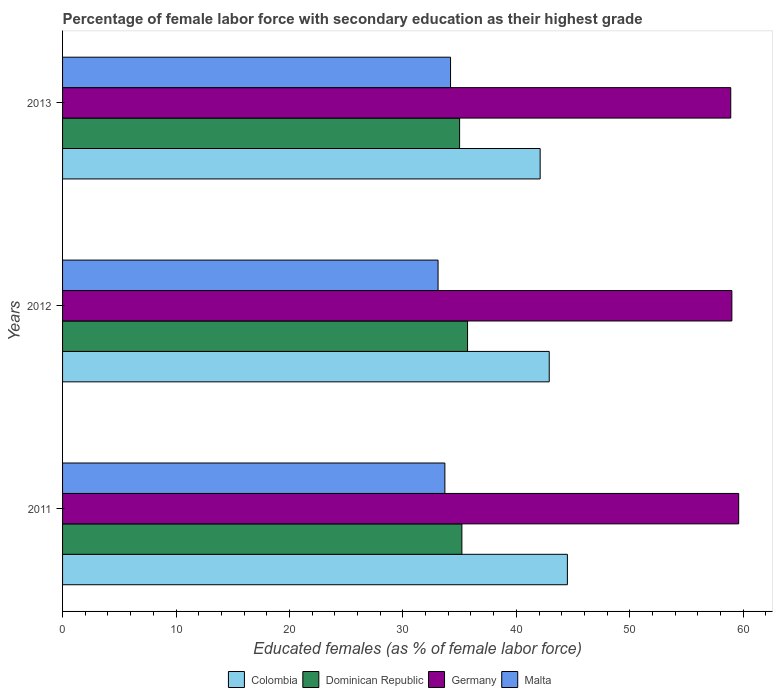Are the number of bars per tick equal to the number of legend labels?
Provide a succinct answer. Yes. How many bars are there on the 2nd tick from the top?
Provide a succinct answer. 4. How many bars are there on the 1st tick from the bottom?
Provide a succinct answer. 4. What is the label of the 2nd group of bars from the top?
Your answer should be very brief. 2012. What is the percentage of female labor force with secondary education in Malta in 2013?
Your answer should be compact. 34.2. Across all years, what is the maximum percentage of female labor force with secondary education in Colombia?
Your answer should be very brief. 44.5. Across all years, what is the minimum percentage of female labor force with secondary education in Malta?
Ensure brevity in your answer.  33.1. What is the total percentage of female labor force with secondary education in Dominican Republic in the graph?
Make the answer very short. 105.9. What is the difference between the percentage of female labor force with secondary education in Colombia in 2011 and that in 2013?
Offer a very short reply. 2.4. What is the difference between the percentage of female labor force with secondary education in Malta in 2011 and the percentage of female labor force with secondary education in Colombia in 2013?
Offer a terse response. -8.4. What is the average percentage of female labor force with secondary education in Germany per year?
Your answer should be compact. 59.17. In the year 2012, what is the difference between the percentage of female labor force with secondary education in Germany and percentage of female labor force with secondary education in Colombia?
Your response must be concise. 16.1. What is the ratio of the percentage of female labor force with secondary education in Germany in 2011 to that in 2013?
Your answer should be compact. 1.01. Is the percentage of female labor force with secondary education in Malta in 2012 less than that in 2013?
Your response must be concise. Yes. What is the difference between the highest and the lowest percentage of female labor force with secondary education in Colombia?
Make the answer very short. 2.4. In how many years, is the percentage of female labor force with secondary education in Malta greater than the average percentage of female labor force with secondary education in Malta taken over all years?
Your answer should be compact. 2. Is the sum of the percentage of female labor force with secondary education in Colombia in 2011 and 2013 greater than the maximum percentage of female labor force with secondary education in Dominican Republic across all years?
Your response must be concise. Yes. How many bars are there?
Provide a succinct answer. 12. Are all the bars in the graph horizontal?
Provide a short and direct response. Yes. Does the graph contain any zero values?
Make the answer very short. No. What is the title of the graph?
Make the answer very short. Percentage of female labor force with secondary education as their highest grade. What is the label or title of the X-axis?
Provide a succinct answer. Educated females (as % of female labor force). What is the Educated females (as % of female labor force) in Colombia in 2011?
Provide a short and direct response. 44.5. What is the Educated females (as % of female labor force) of Dominican Republic in 2011?
Give a very brief answer. 35.2. What is the Educated females (as % of female labor force) in Germany in 2011?
Provide a succinct answer. 59.6. What is the Educated females (as % of female labor force) in Malta in 2011?
Keep it short and to the point. 33.7. What is the Educated females (as % of female labor force) in Colombia in 2012?
Provide a short and direct response. 42.9. What is the Educated females (as % of female labor force) of Dominican Republic in 2012?
Ensure brevity in your answer.  35.7. What is the Educated females (as % of female labor force) in Malta in 2012?
Your answer should be very brief. 33.1. What is the Educated females (as % of female labor force) in Colombia in 2013?
Give a very brief answer. 42.1. What is the Educated females (as % of female labor force) of Dominican Republic in 2013?
Keep it short and to the point. 35. What is the Educated females (as % of female labor force) of Germany in 2013?
Give a very brief answer. 58.9. What is the Educated females (as % of female labor force) in Malta in 2013?
Make the answer very short. 34.2. Across all years, what is the maximum Educated females (as % of female labor force) in Colombia?
Your response must be concise. 44.5. Across all years, what is the maximum Educated females (as % of female labor force) of Dominican Republic?
Make the answer very short. 35.7. Across all years, what is the maximum Educated females (as % of female labor force) of Germany?
Your answer should be very brief. 59.6. Across all years, what is the maximum Educated females (as % of female labor force) of Malta?
Your response must be concise. 34.2. Across all years, what is the minimum Educated females (as % of female labor force) in Colombia?
Offer a very short reply. 42.1. Across all years, what is the minimum Educated females (as % of female labor force) in Dominican Republic?
Your answer should be compact. 35. Across all years, what is the minimum Educated females (as % of female labor force) in Germany?
Your answer should be very brief. 58.9. Across all years, what is the minimum Educated females (as % of female labor force) in Malta?
Provide a succinct answer. 33.1. What is the total Educated females (as % of female labor force) of Colombia in the graph?
Give a very brief answer. 129.5. What is the total Educated females (as % of female labor force) of Dominican Republic in the graph?
Your answer should be very brief. 105.9. What is the total Educated females (as % of female labor force) of Germany in the graph?
Your answer should be very brief. 177.5. What is the total Educated females (as % of female labor force) in Malta in the graph?
Provide a succinct answer. 101. What is the difference between the Educated females (as % of female labor force) of Germany in 2011 and that in 2012?
Your response must be concise. 0.6. What is the difference between the Educated females (as % of female labor force) in Malta in 2011 and that in 2012?
Your answer should be compact. 0.6. What is the difference between the Educated females (as % of female labor force) in Colombia in 2011 and that in 2013?
Keep it short and to the point. 2.4. What is the difference between the Educated females (as % of female labor force) in Malta in 2011 and that in 2013?
Your answer should be very brief. -0.5. What is the difference between the Educated females (as % of female labor force) in Colombia in 2012 and that in 2013?
Offer a terse response. 0.8. What is the difference between the Educated females (as % of female labor force) in Dominican Republic in 2012 and that in 2013?
Ensure brevity in your answer.  0.7. What is the difference between the Educated females (as % of female labor force) of Colombia in 2011 and the Educated females (as % of female labor force) of Germany in 2012?
Provide a succinct answer. -14.5. What is the difference between the Educated females (as % of female labor force) of Dominican Republic in 2011 and the Educated females (as % of female labor force) of Germany in 2012?
Keep it short and to the point. -23.8. What is the difference between the Educated females (as % of female labor force) of Dominican Republic in 2011 and the Educated females (as % of female labor force) of Malta in 2012?
Your response must be concise. 2.1. What is the difference between the Educated females (as % of female labor force) in Colombia in 2011 and the Educated females (as % of female labor force) in Dominican Republic in 2013?
Make the answer very short. 9.5. What is the difference between the Educated females (as % of female labor force) in Colombia in 2011 and the Educated females (as % of female labor force) in Germany in 2013?
Make the answer very short. -14.4. What is the difference between the Educated females (as % of female labor force) of Colombia in 2011 and the Educated females (as % of female labor force) of Malta in 2013?
Provide a short and direct response. 10.3. What is the difference between the Educated females (as % of female labor force) in Dominican Republic in 2011 and the Educated females (as % of female labor force) in Germany in 2013?
Offer a terse response. -23.7. What is the difference between the Educated females (as % of female labor force) in Dominican Republic in 2011 and the Educated females (as % of female labor force) in Malta in 2013?
Your answer should be very brief. 1. What is the difference between the Educated females (as % of female labor force) in Germany in 2011 and the Educated females (as % of female labor force) in Malta in 2013?
Your answer should be compact. 25.4. What is the difference between the Educated females (as % of female labor force) in Colombia in 2012 and the Educated females (as % of female labor force) in Dominican Republic in 2013?
Provide a succinct answer. 7.9. What is the difference between the Educated females (as % of female labor force) in Colombia in 2012 and the Educated females (as % of female labor force) in Germany in 2013?
Give a very brief answer. -16. What is the difference between the Educated females (as % of female labor force) of Dominican Republic in 2012 and the Educated females (as % of female labor force) of Germany in 2013?
Offer a very short reply. -23.2. What is the difference between the Educated females (as % of female labor force) in Dominican Republic in 2012 and the Educated females (as % of female labor force) in Malta in 2013?
Provide a short and direct response. 1.5. What is the difference between the Educated females (as % of female labor force) in Germany in 2012 and the Educated females (as % of female labor force) in Malta in 2013?
Offer a very short reply. 24.8. What is the average Educated females (as % of female labor force) in Colombia per year?
Give a very brief answer. 43.17. What is the average Educated females (as % of female labor force) of Dominican Republic per year?
Provide a short and direct response. 35.3. What is the average Educated females (as % of female labor force) in Germany per year?
Offer a terse response. 59.17. What is the average Educated females (as % of female labor force) in Malta per year?
Ensure brevity in your answer.  33.67. In the year 2011, what is the difference between the Educated females (as % of female labor force) in Colombia and Educated females (as % of female labor force) in Germany?
Keep it short and to the point. -15.1. In the year 2011, what is the difference between the Educated females (as % of female labor force) in Dominican Republic and Educated females (as % of female labor force) in Germany?
Your answer should be compact. -24.4. In the year 2011, what is the difference between the Educated females (as % of female labor force) of Germany and Educated females (as % of female labor force) of Malta?
Your response must be concise. 25.9. In the year 2012, what is the difference between the Educated females (as % of female labor force) in Colombia and Educated females (as % of female labor force) in Germany?
Provide a short and direct response. -16.1. In the year 2012, what is the difference between the Educated females (as % of female labor force) in Colombia and Educated females (as % of female labor force) in Malta?
Your answer should be compact. 9.8. In the year 2012, what is the difference between the Educated females (as % of female labor force) of Dominican Republic and Educated females (as % of female labor force) of Germany?
Provide a succinct answer. -23.3. In the year 2012, what is the difference between the Educated females (as % of female labor force) in Germany and Educated females (as % of female labor force) in Malta?
Make the answer very short. 25.9. In the year 2013, what is the difference between the Educated females (as % of female labor force) of Colombia and Educated females (as % of female labor force) of Dominican Republic?
Give a very brief answer. 7.1. In the year 2013, what is the difference between the Educated females (as % of female labor force) of Colombia and Educated females (as % of female labor force) of Germany?
Your response must be concise. -16.8. In the year 2013, what is the difference between the Educated females (as % of female labor force) of Colombia and Educated females (as % of female labor force) of Malta?
Give a very brief answer. 7.9. In the year 2013, what is the difference between the Educated females (as % of female labor force) of Dominican Republic and Educated females (as % of female labor force) of Germany?
Provide a succinct answer. -23.9. In the year 2013, what is the difference between the Educated females (as % of female labor force) of Germany and Educated females (as % of female labor force) of Malta?
Offer a terse response. 24.7. What is the ratio of the Educated females (as % of female labor force) in Colombia in 2011 to that in 2012?
Provide a succinct answer. 1.04. What is the ratio of the Educated females (as % of female labor force) of Dominican Republic in 2011 to that in 2012?
Your answer should be very brief. 0.99. What is the ratio of the Educated females (as % of female labor force) of Germany in 2011 to that in 2012?
Your answer should be compact. 1.01. What is the ratio of the Educated females (as % of female labor force) of Malta in 2011 to that in 2012?
Your answer should be compact. 1.02. What is the ratio of the Educated females (as % of female labor force) in Colombia in 2011 to that in 2013?
Your answer should be very brief. 1.06. What is the ratio of the Educated females (as % of female labor force) of Dominican Republic in 2011 to that in 2013?
Your answer should be compact. 1.01. What is the ratio of the Educated females (as % of female labor force) in Germany in 2011 to that in 2013?
Offer a terse response. 1.01. What is the ratio of the Educated females (as % of female labor force) in Malta in 2011 to that in 2013?
Ensure brevity in your answer.  0.99. What is the ratio of the Educated females (as % of female labor force) of Colombia in 2012 to that in 2013?
Your answer should be compact. 1.02. What is the ratio of the Educated females (as % of female labor force) of Dominican Republic in 2012 to that in 2013?
Make the answer very short. 1.02. What is the ratio of the Educated females (as % of female labor force) in Germany in 2012 to that in 2013?
Your answer should be compact. 1. What is the ratio of the Educated females (as % of female labor force) in Malta in 2012 to that in 2013?
Provide a succinct answer. 0.97. What is the difference between the highest and the second highest Educated females (as % of female labor force) in Colombia?
Ensure brevity in your answer.  1.6. What is the difference between the highest and the lowest Educated females (as % of female labor force) of Colombia?
Offer a very short reply. 2.4. What is the difference between the highest and the lowest Educated females (as % of female labor force) in Dominican Republic?
Your answer should be very brief. 0.7. What is the difference between the highest and the lowest Educated females (as % of female labor force) in Malta?
Your answer should be very brief. 1.1. 